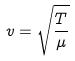Convert formula to latex. <formula><loc_0><loc_0><loc_500><loc_500>v = \sqrt { \frac { T } { \mu } }</formula> 